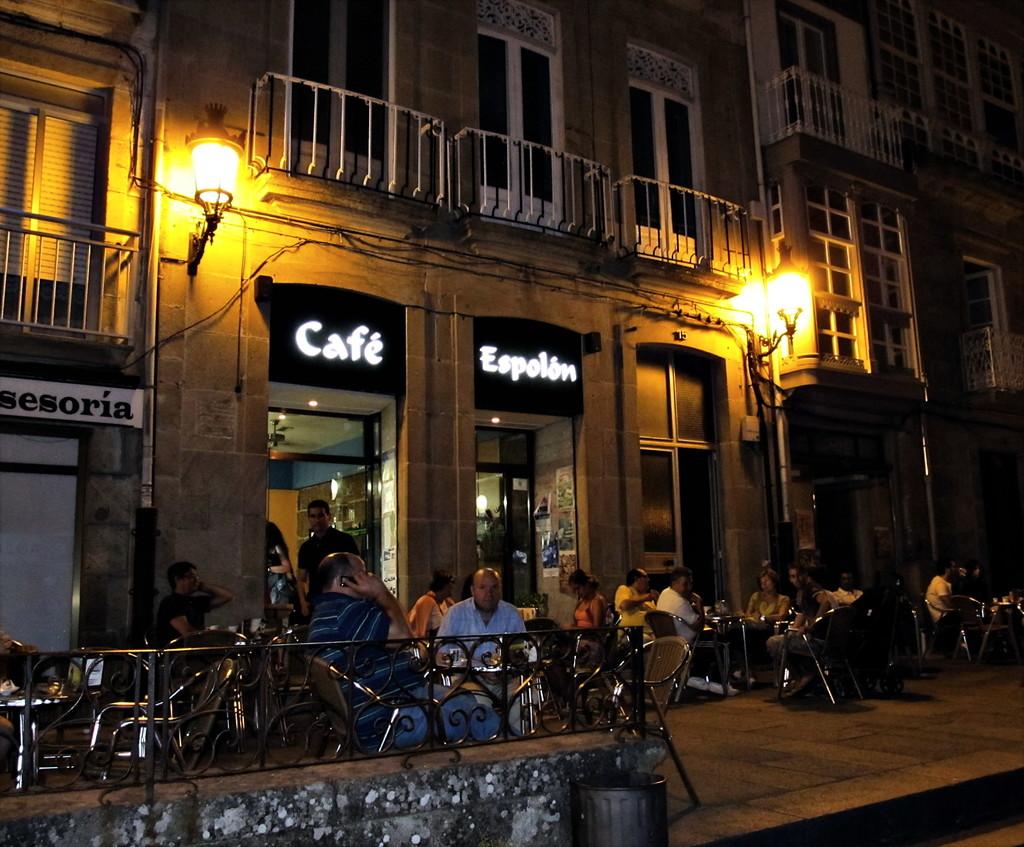What cafe is this?
Offer a terse response. Espolon. 